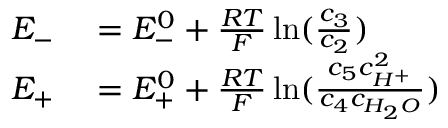<formula> <loc_0><loc_0><loc_500><loc_500>\begin{array} { r l } { E _ { - } } & = E _ { - } ^ { 0 } + \frac { R T } { F } \ln ( \frac { c _ { 3 } } { c _ { 2 } } ) } \\ { E _ { + } } & = E _ { + } ^ { 0 } + \frac { R T } { F } \ln ( \frac { c _ { 5 } c _ { H ^ { + } } ^ { 2 } } { c _ { 4 } c _ { H _ { 2 } O } } ) } \end{array}</formula> 